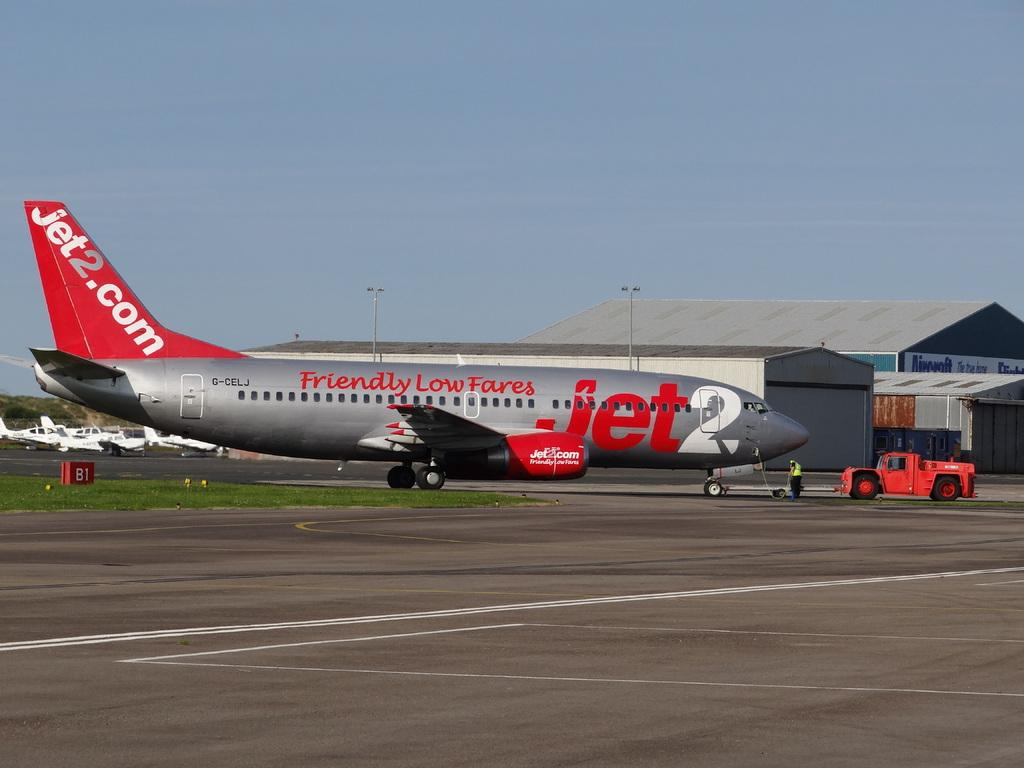<image>
Describe the image concisely. The airplane has a URL link, "jet2.com," painted on its tail. 